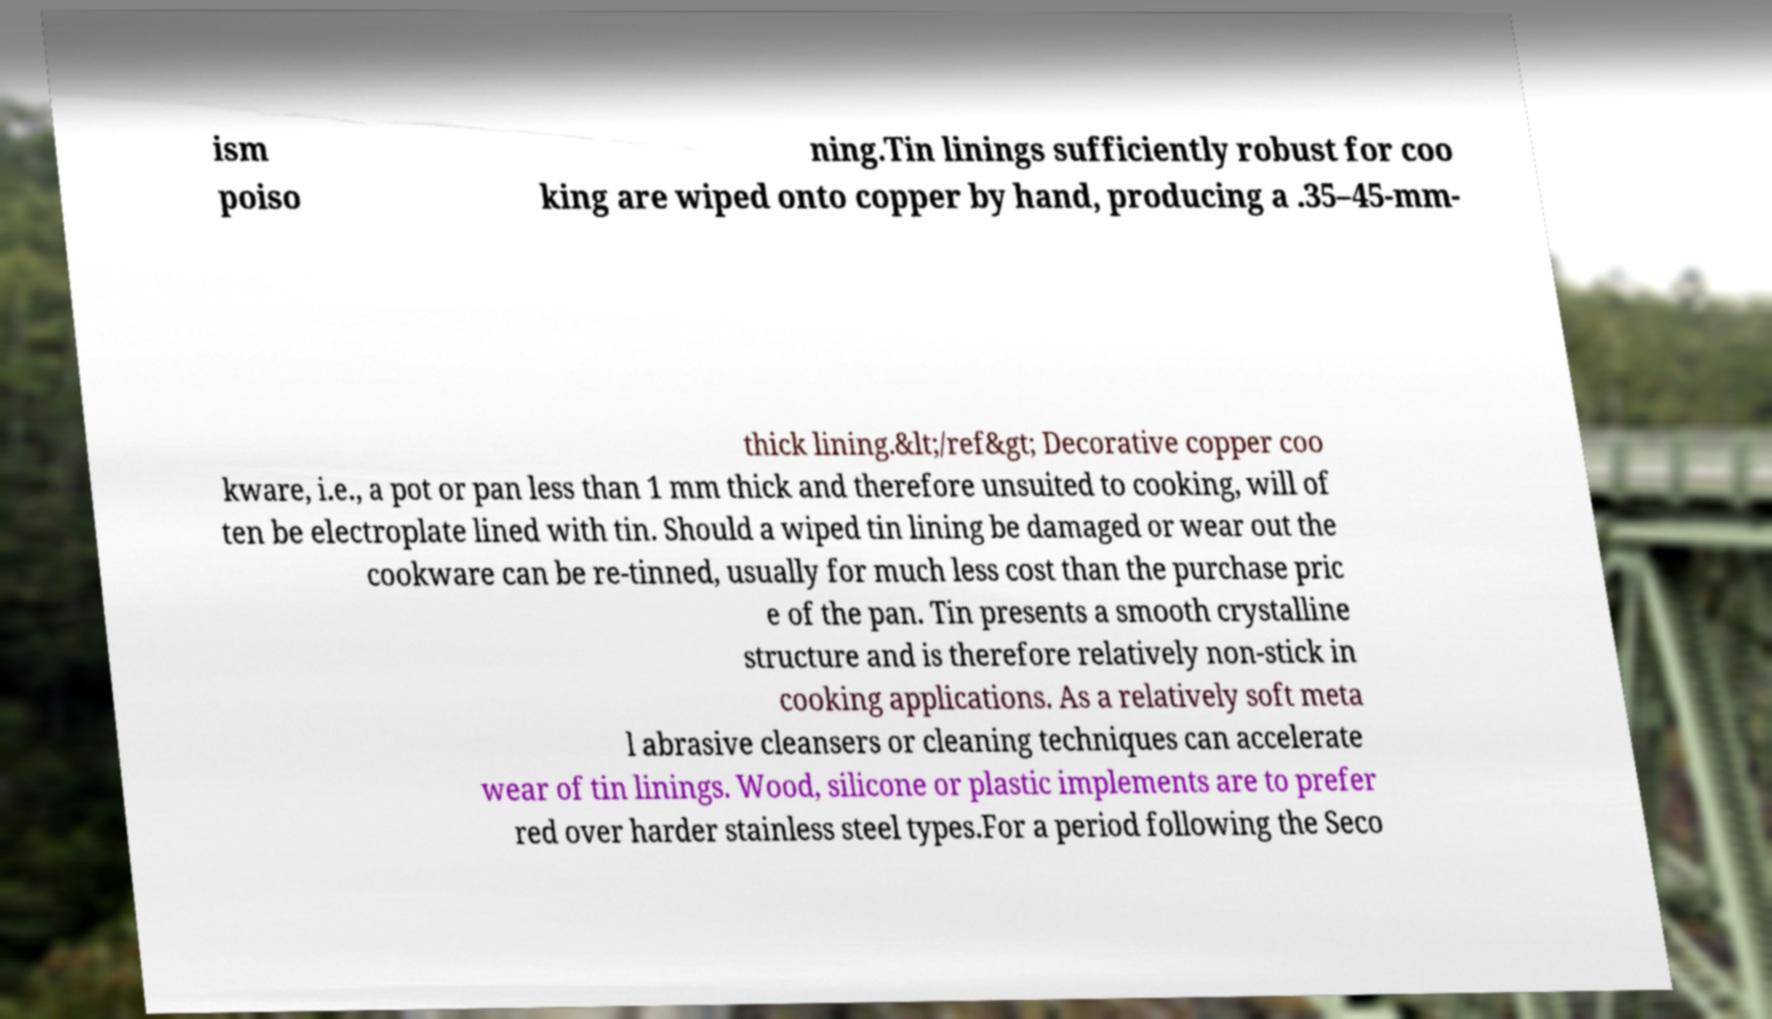Can you read and provide the text displayed in the image?This photo seems to have some interesting text. Can you extract and type it out for me? ism poiso ning.Tin linings sufficiently robust for coo king are wiped onto copper by hand, producing a .35–45-mm- thick lining.&lt;/ref&gt; Decorative copper coo kware, i.e., a pot or pan less than 1 mm thick and therefore unsuited to cooking, will of ten be electroplate lined with tin. Should a wiped tin lining be damaged or wear out the cookware can be re-tinned, usually for much less cost than the purchase pric e of the pan. Tin presents a smooth crystalline structure and is therefore relatively non-stick in cooking applications. As a relatively soft meta l abrasive cleansers or cleaning techniques can accelerate wear of tin linings. Wood, silicone or plastic implements are to prefer red over harder stainless steel types.For a period following the Seco 